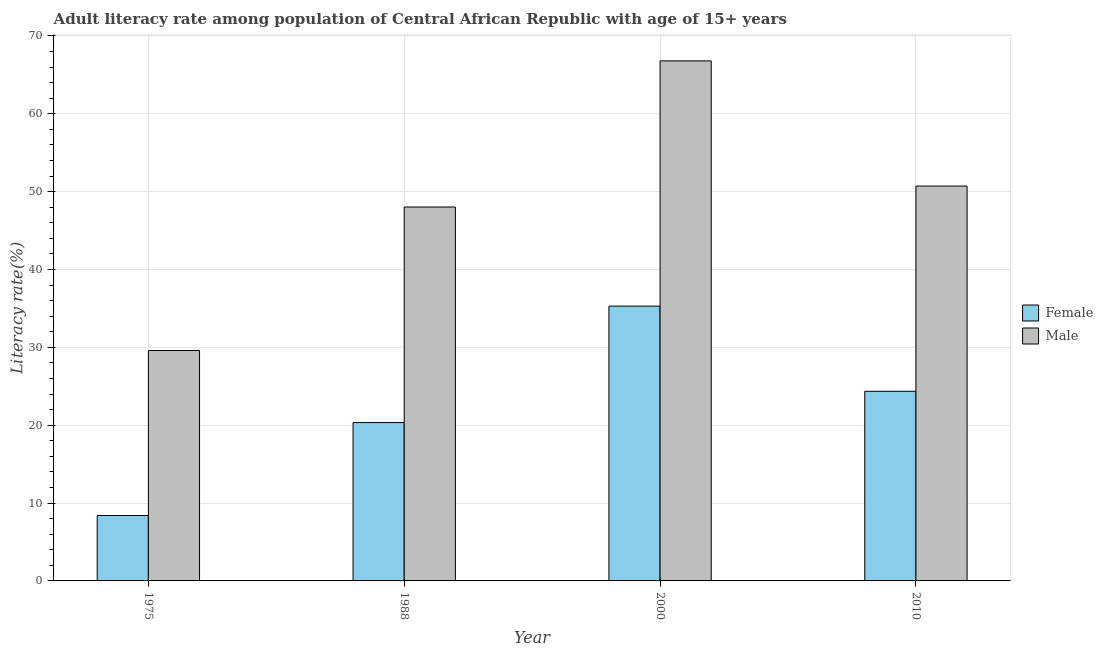How many different coloured bars are there?
Offer a very short reply. 2. How many groups of bars are there?
Offer a very short reply. 4. Are the number of bars per tick equal to the number of legend labels?
Offer a terse response. Yes. What is the label of the 1st group of bars from the left?
Provide a short and direct response. 1975. In how many cases, is the number of bars for a given year not equal to the number of legend labels?
Provide a succinct answer. 0. What is the male adult literacy rate in 2010?
Offer a terse response. 50.71. Across all years, what is the maximum female adult literacy rate?
Provide a short and direct response. 35.29. Across all years, what is the minimum male adult literacy rate?
Your response must be concise. 29.59. In which year was the female adult literacy rate minimum?
Your response must be concise. 1975. What is the total male adult literacy rate in the graph?
Your response must be concise. 195.12. What is the difference between the male adult literacy rate in 1975 and that in 1988?
Provide a short and direct response. -18.43. What is the difference between the female adult literacy rate in 1988 and the male adult literacy rate in 2010?
Make the answer very short. -4.02. What is the average female adult literacy rate per year?
Your answer should be compact. 22.1. In how many years, is the female adult literacy rate greater than 54 %?
Provide a short and direct response. 0. What is the ratio of the female adult literacy rate in 1975 to that in 2010?
Your answer should be compact. 0.34. Is the difference between the female adult literacy rate in 1975 and 1988 greater than the difference between the male adult literacy rate in 1975 and 1988?
Provide a succinct answer. No. What is the difference between the highest and the second highest male adult literacy rate?
Your answer should be compact. 16.08. What is the difference between the highest and the lowest male adult literacy rate?
Ensure brevity in your answer.  37.2. In how many years, is the male adult literacy rate greater than the average male adult literacy rate taken over all years?
Make the answer very short. 2. What does the 2nd bar from the right in 1975 represents?
Your answer should be very brief. Female. How many bars are there?
Make the answer very short. 8. Are all the bars in the graph horizontal?
Make the answer very short. No. Are the values on the major ticks of Y-axis written in scientific E-notation?
Make the answer very short. No. Where does the legend appear in the graph?
Your answer should be compact. Center right. How many legend labels are there?
Make the answer very short. 2. What is the title of the graph?
Your response must be concise. Adult literacy rate among population of Central African Republic with age of 15+ years. Does "Research and Development" appear as one of the legend labels in the graph?
Make the answer very short. No. What is the label or title of the X-axis?
Ensure brevity in your answer.  Year. What is the label or title of the Y-axis?
Your answer should be compact. Literacy rate(%). What is the Literacy rate(%) in Female in 1975?
Offer a terse response. 8.4. What is the Literacy rate(%) in Male in 1975?
Your answer should be very brief. 29.59. What is the Literacy rate(%) of Female in 1988?
Your answer should be very brief. 20.34. What is the Literacy rate(%) in Male in 1988?
Keep it short and to the point. 48.02. What is the Literacy rate(%) in Female in 2000?
Provide a short and direct response. 35.29. What is the Literacy rate(%) of Male in 2000?
Your answer should be compact. 66.79. What is the Literacy rate(%) in Female in 2010?
Offer a very short reply. 24.36. What is the Literacy rate(%) in Male in 2010?
Your response must be concise. 50.71. Across all years, what is the maximum Literacy rate(%) in Female?
Provide a succinct answer. 35.29. Across all years, what is the maximum Literacy rate(%) in Male?
Your response must be concise. 66.79. Across all years, what is the minimum Literacy rate(%) of Female?
Make the answer very short. 8.4. Across all years, what is the minimum Literacy rate(%) in Male?
Your answer should be very brief. 29.59. What is the total Literacy rate(%) of Female in the graph?
Keep it short and to the point. 88.38. What is the total Literacy rate(%) of Male in the graph?
Provide a short and direct response. 195.12. What is the difference between the Literacy rate(%) in Female in 1975 and that in 1988?
Give a very brief answer. -11.94. What is the difference between the Literacy rate(%) in Male in 1975 and that in 1988?
Give a very brief answer. -18.43. What is the difference between the Literacy rate(%) in Female in 1975 and that in 2000?
Make the answer very short. -26.89. What is the difference between the Literacy rate(%) in Male in 1975 and that in 2000?
Make the answer very short. -37.2. What is the difference between the Literacy rate(%) of Female in 1975 and that in 2010?
Make the answer very short. -15.96. What is the difference between the Literacy rate(%) in Male in 1975 and that in 2010?
Offer a very short reply. -21.12. What is the difference between the Literacy rate(%) of Female in 1988 and that in 2000?
Your answer should be compact. -14.95. What is the difference between the Literacy rate(%) in Male in 1988 and that in 2000?
Your answer should be compact. -18.77. What is the difference between the Literacy rate(%) of Female in 1988 and that in 2010?
Keep it short and to the point. -4.02. What is the difference between the Literacy rate(%) in Male in 1988 and that in 2010?
Make the answer very short. -2.69. What is the difference between the Literacy rate(%) in Female in 2000 and that in 2010?
Your response must be concise. 10.94. What is the difference between the Literacy rate(%) in Male in 2000 and that in 2010?
Keep it short and to the point. 16.08. What is the difference between the Literacy rate(%) in Female in 1975 and the Literacy rate(%) in Male in 1988?
Ensure brevity in your answer.  -39.62. What is the difference between the Literacy rate(%) in Female in 1975 and the Literacy rate(%) in Male in 2000?
Ensure brevity in your answer.  -58.39. What is the difference between the Literacy rate(%) of Female in 1975 and the Literacy rate(%) of Male in 2010?
Your response must be concise. -42.31. What is the difference between the Literacy rate(%) in Female in 1988 and the Literacy rate(%) in Male in 2000?
Your answer should be compact. -46.45. What is the difference between the Literacy rate(%) of Female in 1988 and the Literacy rate(%) of Male in 2010?
Provide a succinct answer. -30.38. What is the difference between the Literacy rate(%) in Female in 2000 and the Literacy rate(%) in Male in 2010?
Give a very brief answer. -15.42. What is the average Literacy rate(%) in Female per year?
Ensure brevity in your answer.  22.1. What is the average Literacy rate(%) in Male per year?
Provide a short and direct response. 48.78. In the year 1975, what is the difference between the Literacy rate(%) of Female and Literacy rate(%) of Male?
Provide a short and direct response. -21.19. In the year 1988, what is the difference between the Literacy rate(%) of Female and Literacy rate(%) of Male?
Ensure brevity in your answer.  -27.68. In the year 2000, what is the difference between the Literacy rate(%) of Female and Literacy rate(%) of Male?
Give a very brief answer. -31.5. In the year 2010, what is the difference between the Literacy rate(%) in Female and Literacy rate(%) in Male?
Give a very brief answer. -26.36. What is the ratio of the Literacy rate(%) of Female in 1975 to that in 1988?
Your answer should be compact. 0.41. What is the ratio of the Literacy rate(%) of Male in 1975 to that in 1988?
Your response must be concise. 0.62. What is the ratio of the Literacy rate(%) in Female in 1975 to that in 2000?
Your response must be concise. 0.24. What is the ratio of the Literacy rate(%) in Male in 1975 to that in 2000?
Your answer should be compact. 0.44. What is the ratio of the Literacy rate(%) of Female in 1975 to that in 2010?
Offer a terse response. 0.34. What is the ratio of the Literacy rate(%) of Male in 1975 to that in 2010?
Make the answer very short. 0.58. What is the ratio of the Literacy rate(%) in Female in 1988 to that in 2000?
Keep it short and to the point. 0.58. What is the ratio of the Literacy rate(%) in Male in 1988 to that in 2000?
Offer a terse response. 0.72. What is the ratio of the Literacy rate(%) in Female in 1988 to that in 2010?
Keep it short and to the point. 0.83. What is the ratio of the Literacy rate(%) in Male in 1988 to that in 2010?
Your answer should be compact. 0.95. What is the ratio of the Literacy rate(%) in Female in 2000 to that in 2010?
Offer a very short reply. 1.45. What is the ratio of the Literacy rate(%) in Male in 2000 to that in 2010?
Ensure brevity in your answer.  1.32. What is the difference between the highest and the second highest Literacy rate(%) of Female?
Your answer should be very brief. 10.94. What is the difference between the highest and the second highest Literacy rate(%) of Male?
Offer a very short reply. 16.08. What is the difference between the highest and the lowest Literacy rate(%) in Female?
Offer a terse response. 26.89. What is the difference between the highest and the lowest Literacy rate(%) in Male?
Ensure brevity in your answer.  37.2. 